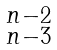Convert formula to latex. <formula><loc_0><loc_0><loc_500><loc_500>\begin{smallmatrix} n - 2 \\ n - 3 \end{smallmatrix}</formula> 